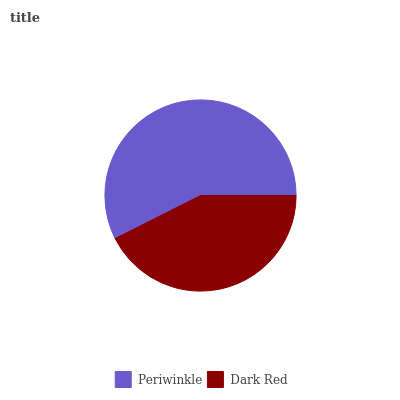Is Dark Red the minimum?
Answer yes or no. Yes. Is Periwinkle the maximum?
Answer yes or no. Yes. Is Dark Red the maximum?
Answer yes or no. No. Is Periwinkle greater than Dark Red?
Answer yes or no. Yes. Is Dark Red less than Periwinkle?
Answer yes or no. Yes. Is Dark Red greater than Periwinkle?
Answer yes or no. No. Is Periwinkle less than Dark Red?
Answer yes or no. No. Is Periwinkle the high median?
Answer yes or no. Yes. Is Dark Red the low median?
Answer yes or no. Yes. Is Dark Red the high median?
Answer yes or no. No. Is Periwinkle the low median?
Answer yes or no. No. 